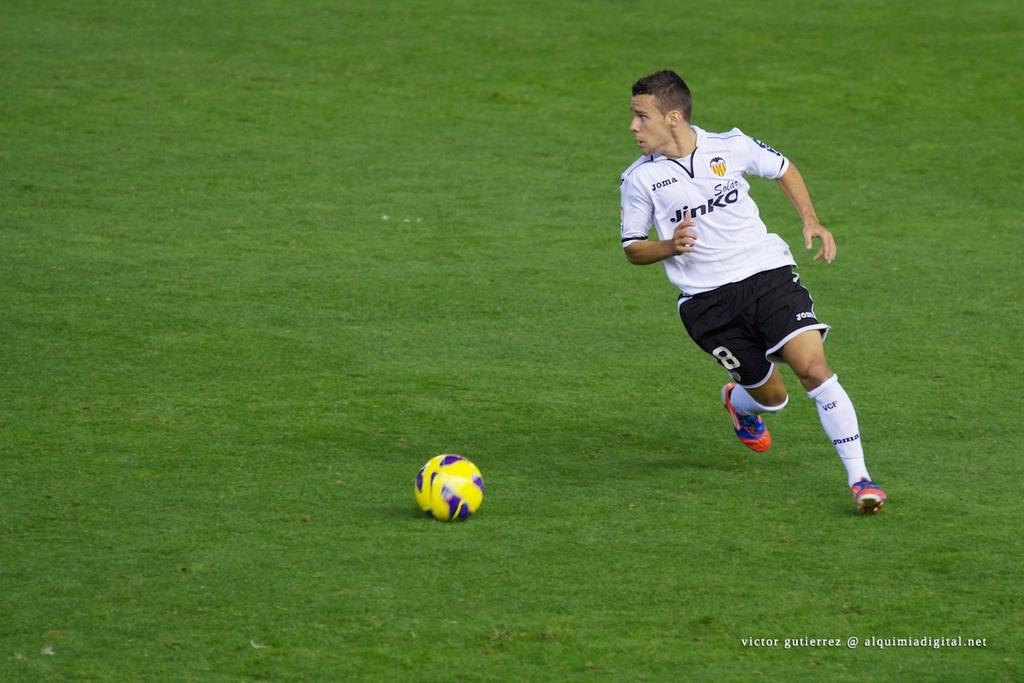What is the person in the image doing? There is a person running in the image. Where is the person running in the image? The person is running in the center of the image. What object is on the ground in the image? There is a football on the ground in the image. What type of scale can be seen in the image? There is no scale present in the image. What kind of camera is being used to capture the image? The image does not show the camera used to capture it. 